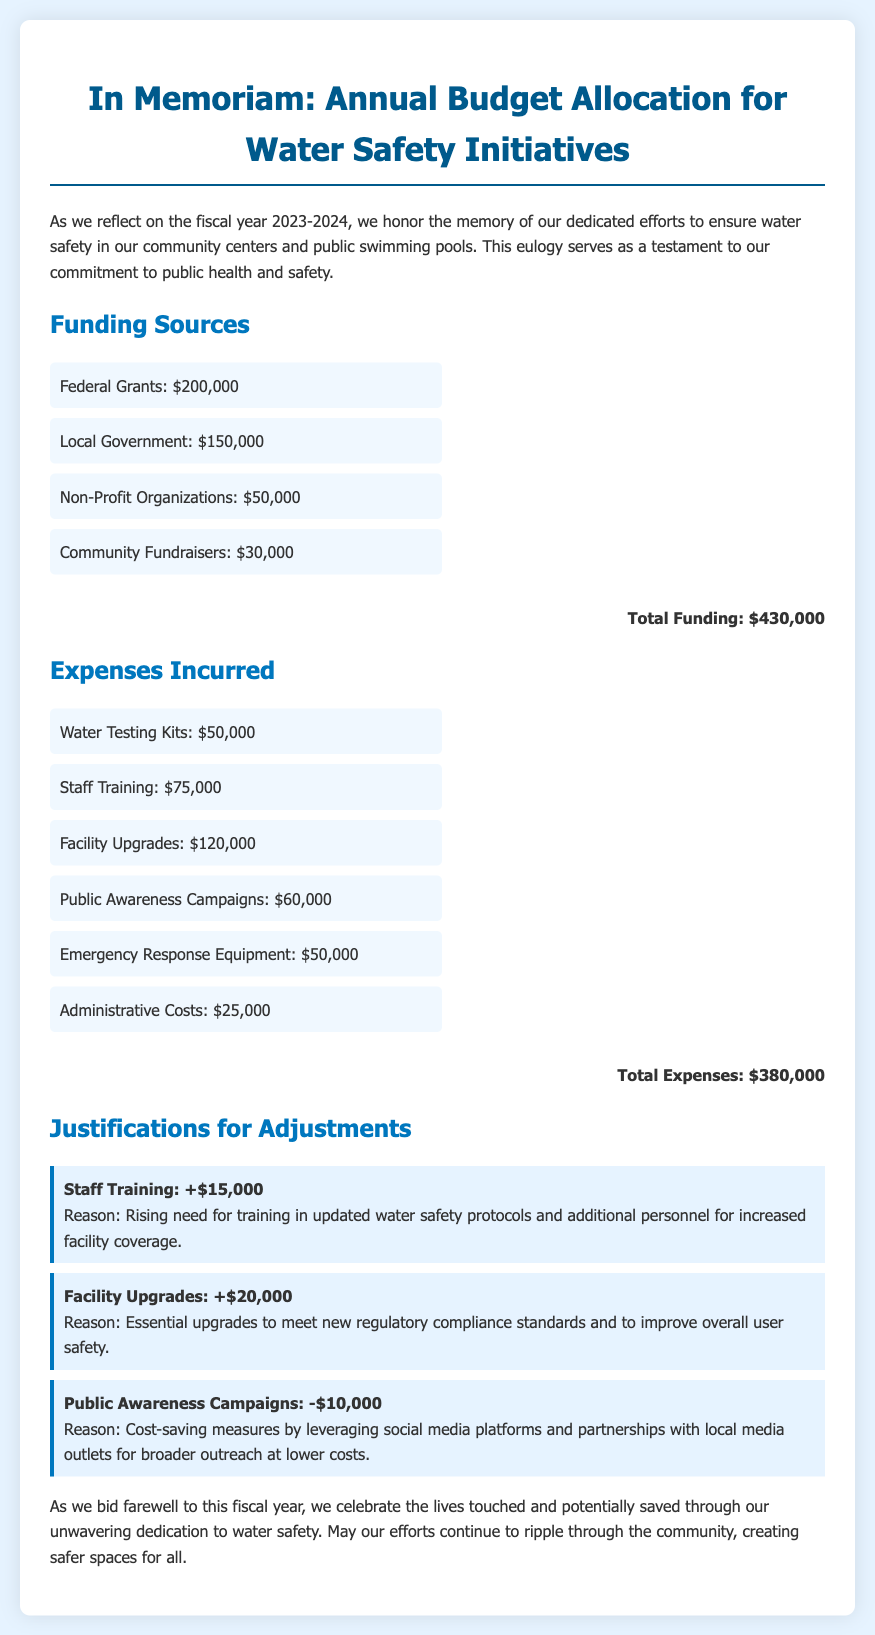What is the total funding for water safety initiatives? The total funding is calculated by summing all funding sources mentioned in the document, which are Federal Grants, Local Government, Non-Profit Organizations, and Community Fundraisers.
Answer: $430,000 What is the largest expense incurred? The largest expense is identified among all listed expenses, which is Facility Upgrades at $120,000.
Answer: Facility Upgrades How much was allocated for public awareness campaigns? The budget specifically listed for public awareness campaigns shows an expense of $60,000.
Answer: $60,000 What is the reason for the adjustment in staff training budget? The reason given for the adjustment reflects the rising need for training in updated water safety protocols and additional personnel.
Answer: Rising need for training How much was spent on administrative costs? The document provides the specific figure allocated for administrative costs, which is stated clearly.
Answer: $25,000 What were the funding contributions from Non-Profit Organizations? The document notes that Non-Profit Organizations contributed a specific amount to the funding sources.
Answer: $50,000 By how much was the facility upgrades budget increased? The adjustment for facility upgrades indicates an increase of a certain amount for compliance and safety improvements.
Answer: +$20,000 What was the total expense incurred for water testing kits? According to the document, the specific amount allocated for water testing kits is detailed as an expense.
Answer: $50,000 What cost-saving measure was taken for public awareness campaigns? The document outlines a method employed to save costs by leveraging specific platforms and partnerships.
Answer: Leveraging social media platforms 